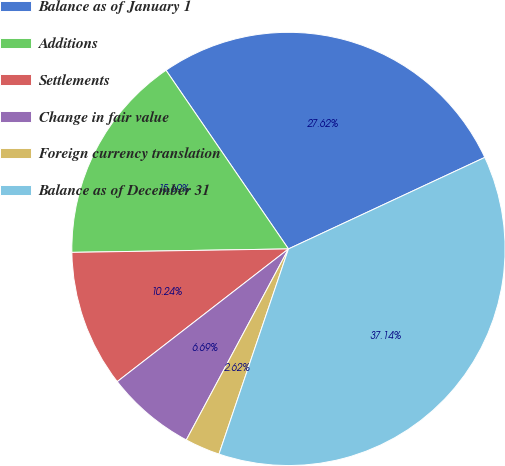Convert chart. <chart><loc_0><loc_0><loc_500><loc_500><pie_chart><fcel>Balance as of January 1<fcel>Additions<fcel>Settlements<fcel>Change in fair value<fcel>Foreign currency translation<fcel>Balance as of December 31<nl><fcel>27.62%<fcel>15.69%<fcel>10.24%<fcel>6.69%<fcel>2.62%<fcel>37.14%<nl></chart> 